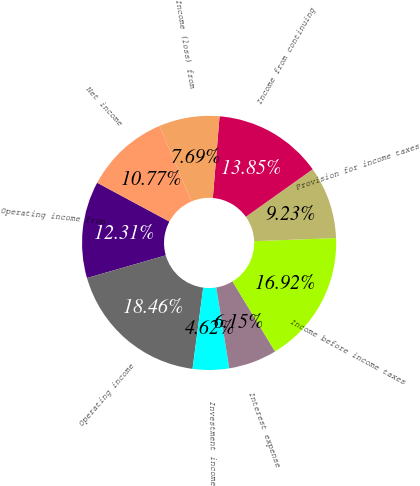Convert chart. <chart><loc_0><loc_0><loc_500><loc_500><pie_chart><fcel>Operating income from<fcel>Operating income<fcel>Investment income<fcel>Interest expense<fcel>Income before income taxes<fcel>Provision for income taxes<fcel>Income from continuing<fcel>Income (loss) from<fcel>Net income<nl><fcel>12.31%<fcel>18.46%<fcel>4.62%<fcel>6.15%<fcel>16.92%<fcel>9.23%<fcel>13.85%<fcel>7.69%<fcel>10.77%<nl></chart> 